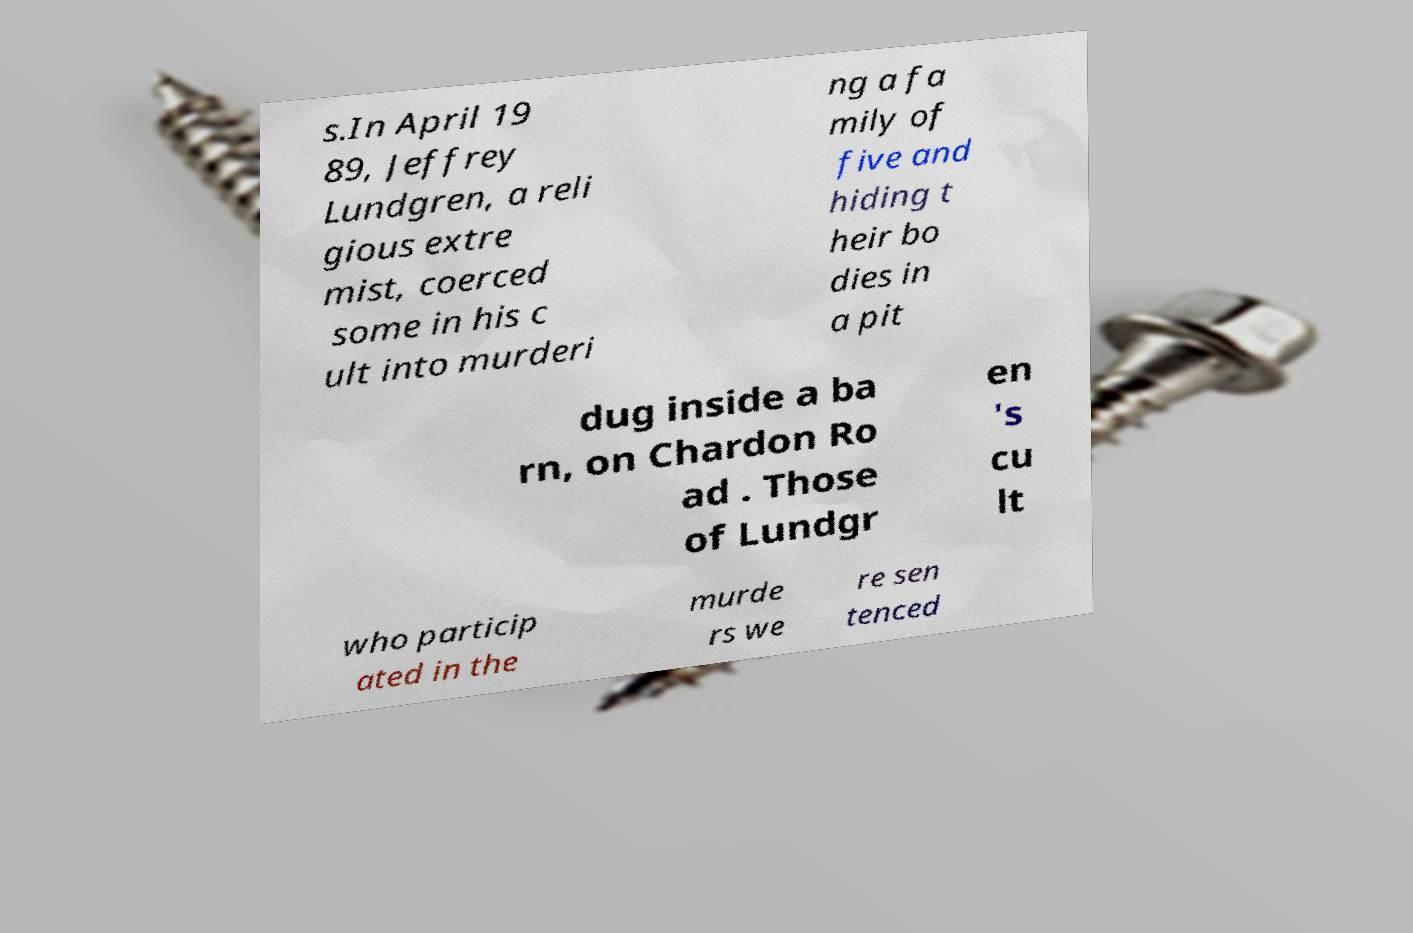Please identify and transcribe the text found in this image. s.In April 19 89, Jeffrey Lundgren, a reli gious extre mist, coerced some in his c ult into murderi ng a fa mily of five and hiding t heir bo dies in a pit dug inside a ba rn, on Chardon Ro ad . Those of Lundgr en 's cu lt who particip ated in the murde rs we re sen tenced 